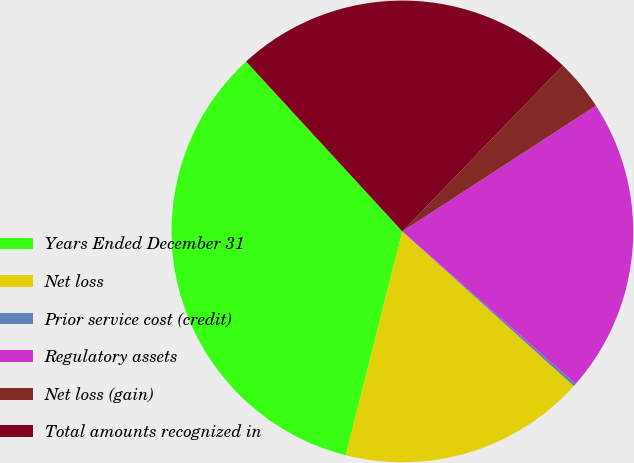<chart> <loc_0><loc_0><loc_500><loc_500><pie_chart><fcel>Years Ended December 31<fcel>Net loss<fcel>Prior service cost (credit)<fcel>Regulatory assets<fcel>Net loss (gain)<fcel>Total amounts recognized in<nl><fcel>34.23%<fcel>17.26%<fcel>0.19%<fcel>20.66%<fcel>3.59%<fcel>24.07%<nl></chart> 